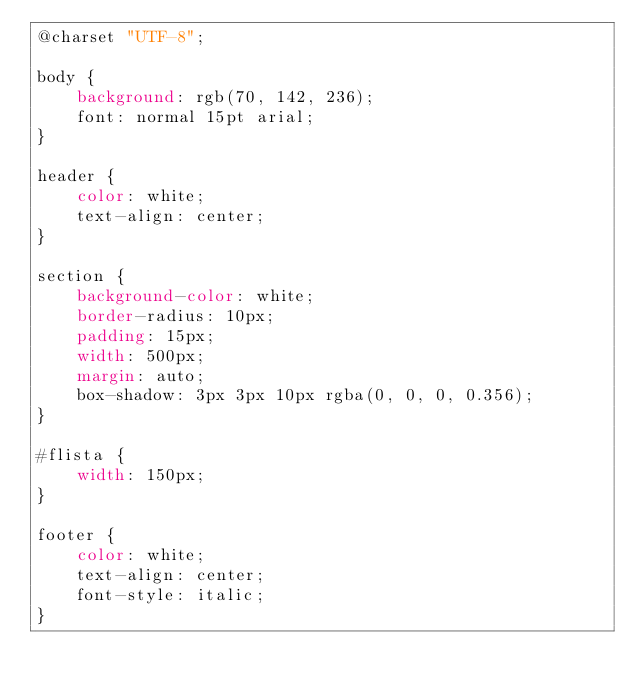Convert code to text. <code><loc_0><loc_0><loc_500><loc_500><_CSS_>@charset "UTF-8";

body {
    background: rgb(70, 142, 236);
    font: normal 15pt arial;
}

header {
    color: white;
    text-align: center;
}

section {
    background-color: white;
    border-radius: 10px;
    padding: 15px;
    width: 500px;
    margin: auto;
    box-shadow: 3px 3px 10px rgba(0, 0, 0, 0.356);
}

#flista {
    width: 150px;
}

footer {
    color: white;
    text-align: center;
    font-style: italic;
}</code> 